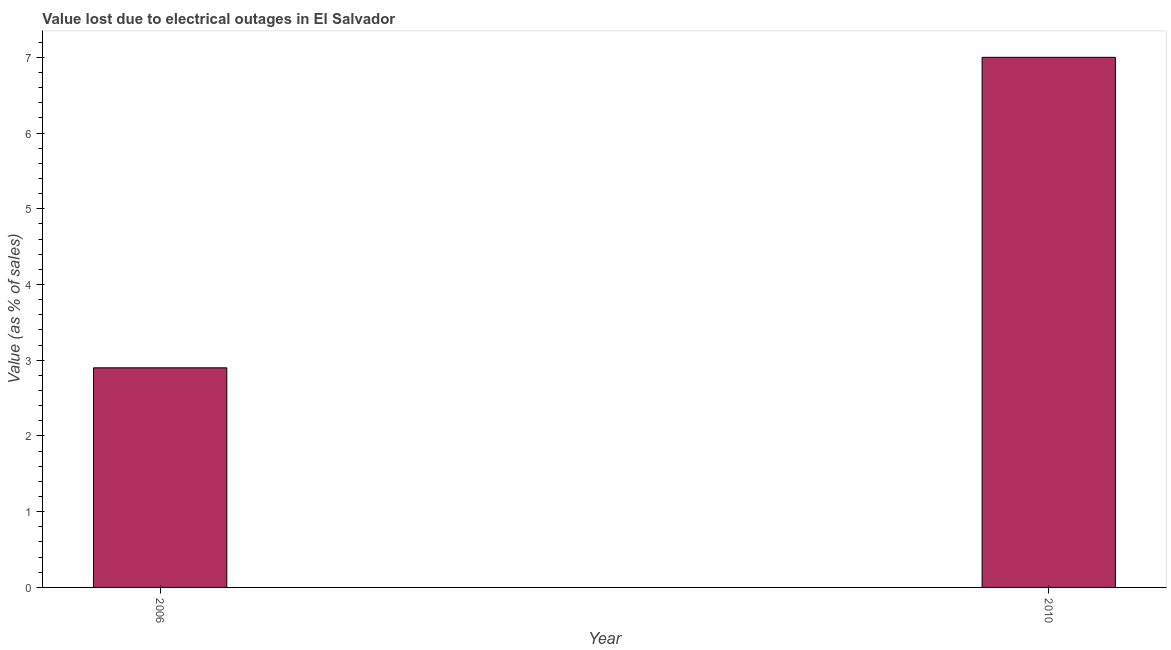What is the title of the graph?
Your answer should be compact. Value lost due to electrical outages in El Salvador. What is the label or title of the Y-axis?
Provide a short and direct response. Value (as % of sales). What is the value lost due to electrical outages in 2010?
Offer a terse response. 7. Across all years, what is the minimum value lost due to electrical outages?
Your answer should be compact. 2.9. In which year was the value lost due to electrical outages maximum?
Your response must be concise. 2010. In which year was the value lost due to electrical outages minimum?
Your response must be concise. 2006. What is the average value lost due to electrical outages per year?
Your response must be concise. 4.95. What is the median value lost due to electrical outages?
Give a very brief answer. 4.95. In how many years, is the value lost due to electrical outages greater than 5.4 %?
Provide a short and direct response. 1. Do a majority of the years between 2006 and 2010 (inclusive) have value lost due to electrical outages greater than 1 %?
Provide a short and direct response. Yes. What is the ratio of the value lost due to electrical outages in 2006 to that in 2010?
Your answer should be very brief. 0.41. Is the value lost due to electrical outages in 2006 less than that in 2010?
Keep it short and to the point. Yes. In how many years, is the value lost due to electrical outages greater than the average value lost due to electrical outages taken over all years?
Ensure brevity in your answer.  1. Are all the bars in the graph horizontal?
Your response must be concise. No. How many years are there in the graph?
Give a very brief answer. 2. What is the Value (as % of sales) in 2006?
Provide a short and direct response. 2.9. What is the ratio of the Value (as % of sales) in 2006 to that in 2010?
Ensure brevity in your answer.  0.41. 